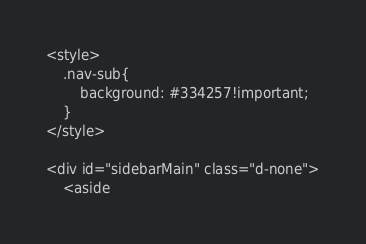<code> <loc_0><loc_0><loc_500><loc_500><_PHP_><style>
    .nav-sub{
        background: #334257!important;
    }
</style>

<div id="sidebarMain" class="d-none">
    <aside</code> 